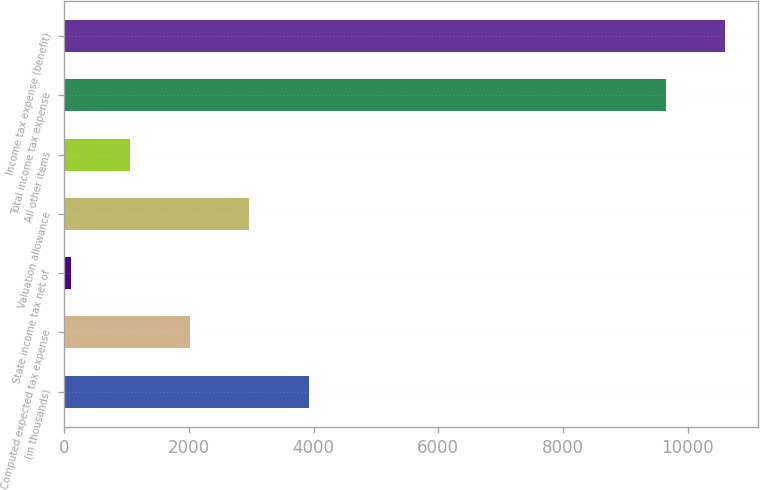Convert chart. <chart><loc_0><loc_0><loc_500><loc_500><bar_chart><fcel>(in thousands)<fcel>Computed expected tax expense<fcel>State income tax net of<fcel>Valuation allowance<fcel>All other items<fcel>Total income tax expense<fcel>Income tax expense (benefit)<nl><fcel>3923.6<fcel>2015.8<fcel>108<fcel>2969.7<fcel>1061.9<fcel>9647<fcel>10600.9<nl></chart> 